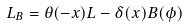<formula> <loc_0><loc_0><loc_500><loc_500>L _ { B } = \theta ( - x ) L - \delta ( x ) B ( \phi )</formula> 